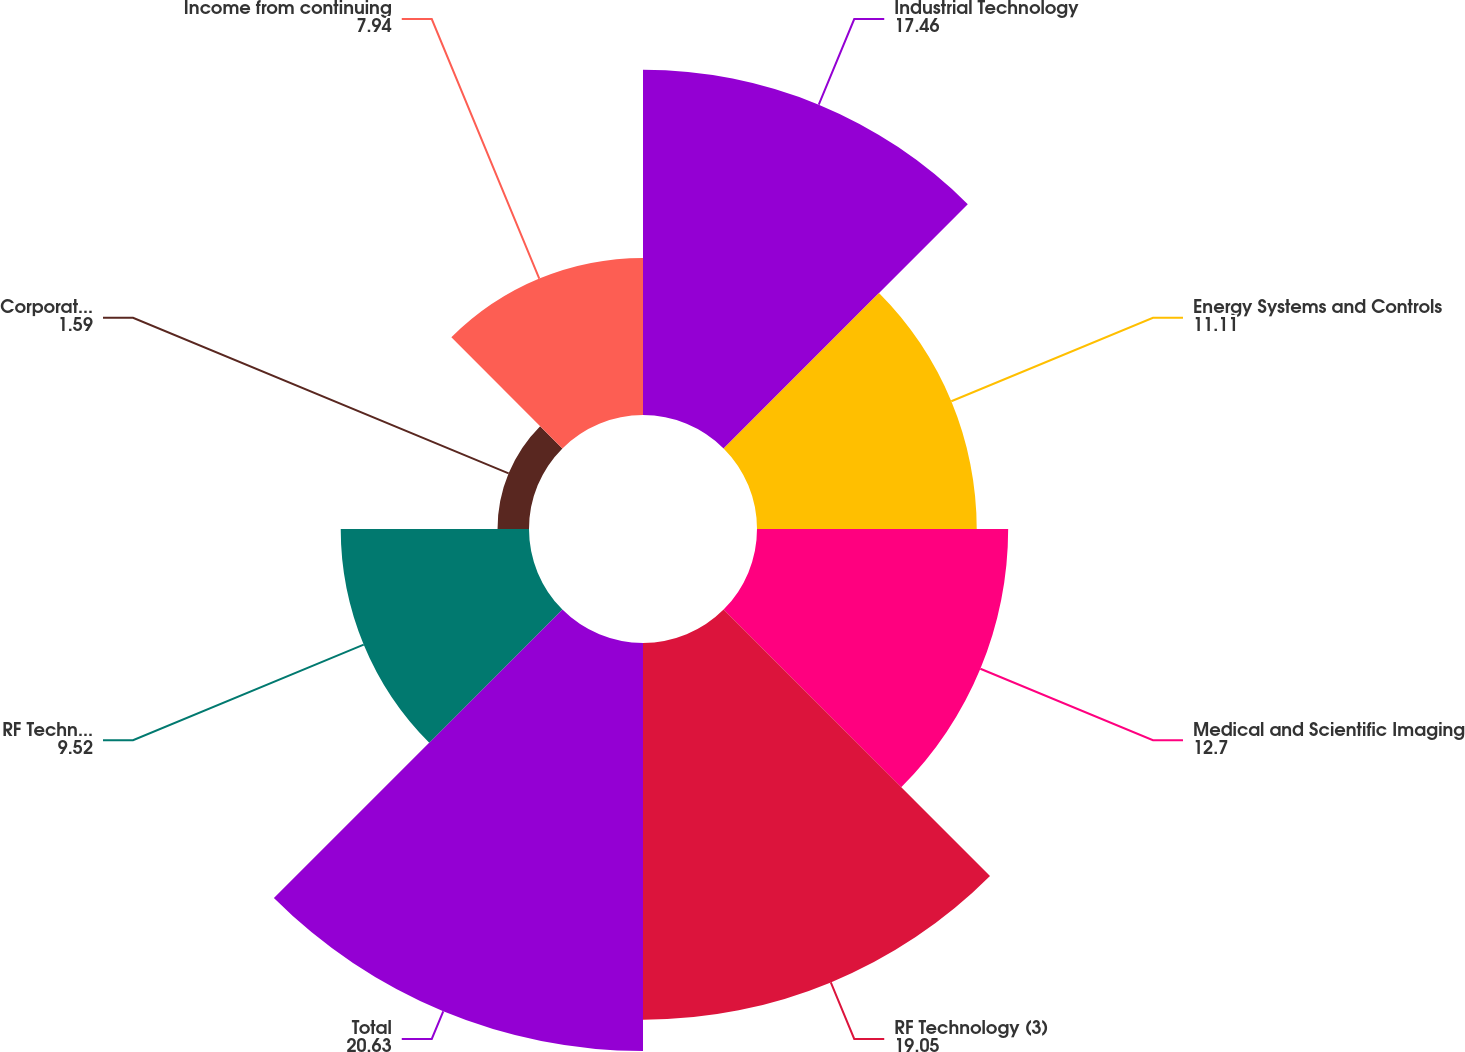Convert chart. <chart><loc_0><loc_0><loc_500><loc_500><pie_chart><fcel>Industrial Technology<fcel>Energy Systems and Controls<fcel>Medical and Scientific Imaging<fcel>RF Technology (3)<fcel>Total<fcel>RF Technology<fcel>Corporate administrative<fcel>Income from continuing<nl><fcel>17.46%<fcel>11.11%<fcel>12.7%<fcel>19.05%<fcel>20.63%<fcel>9.52%<fcel>1.59%<fcel>7.94%<nl></chart> 